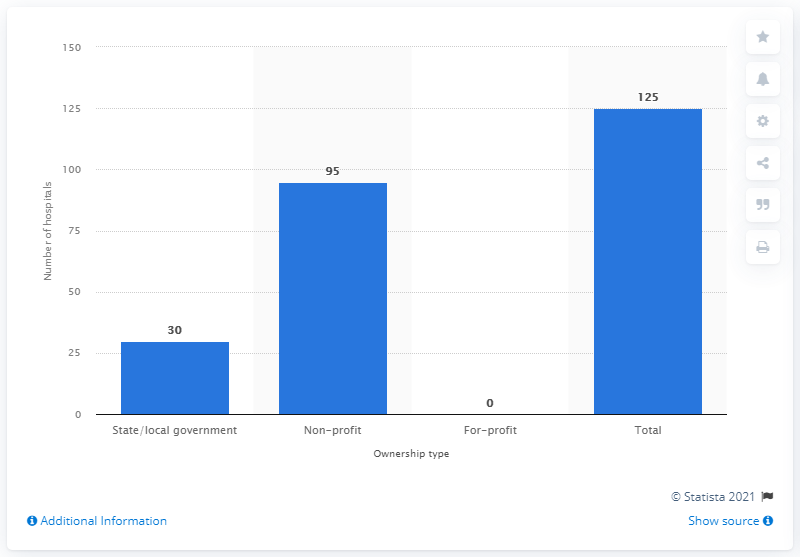Indicate a few pertinent items in this graphic. In 2019, there were 30 hospitals in Minnesota that were owned by the state or the local government. 